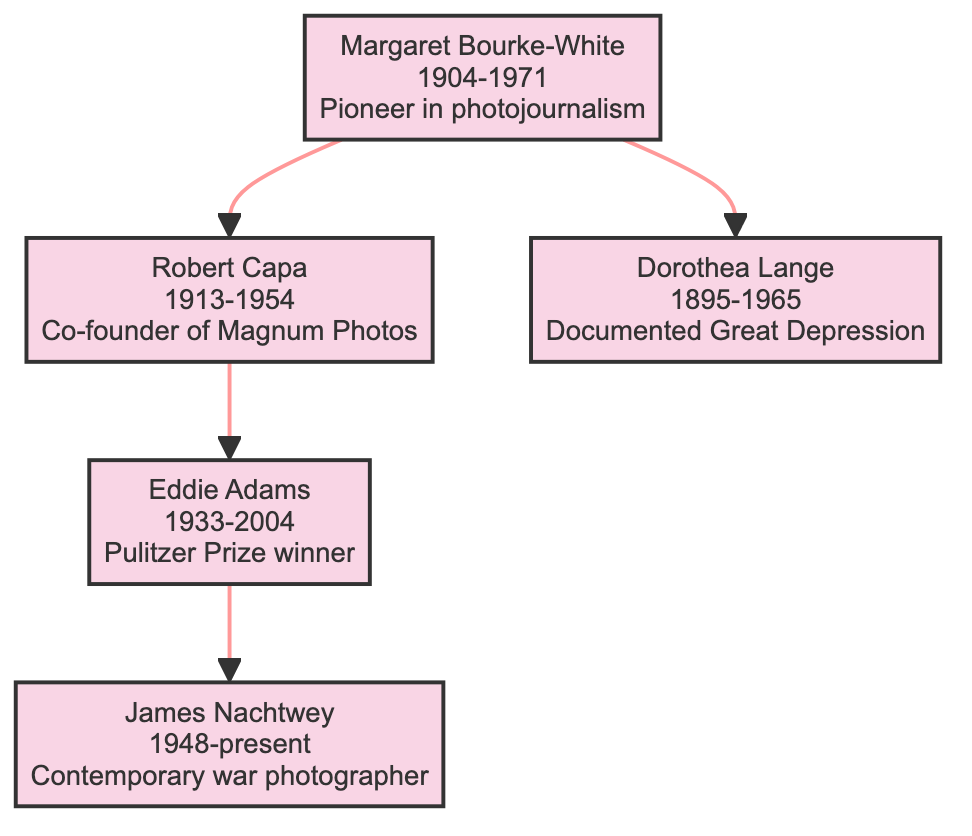What is the birth year of Margaret Bourke-White? The diagram shows the node for Margaret Bourke-White, and at the bottom of this node, it indicates the year 1904. Therefore, her birth year is 1904.
Answer: 1904 How many notable assignments did Robert Capa have? Robert Capa's node lists three notable assignments, which are the Spanish Civil War, D-Day landings, and the First Indochina War. The total count of these assignments is three.
Answer: 3 Who documented the Great Depression? The diagram points to Dorothea Lange’s node, which states "Documented the effects of the Great Depression." Therefore, Dorothea Lange is the person who documented the Great Depression.
Answer: Dorothea Lange Which photojournalist co-founded Magnum Photos? The information in the diagram states that Robert Capa is noted as the co-founder of Magnum Photos, making him the correct answer to this question.
Answer: Robert Capa Who is the contemporary war photographer in the family tree? Looking at the diagram, James Nachtwey is labeled as a "Contemporary war photographer," indicating that he fits this description.
Answer: James Nachtwey What impact did Eddie Adams have on public opinion? The diagram notes Eddie Adams’ impact as having "highlighted the power of photojournalism in influencing public opinion," summarizing his significant role.
Answer: Highlighted the power of photojournalism Which two renowned photojournalists documented World War II events? By examining the relationships and notable assignments in the diagram, both Margaret Bourke-White and Robert Capa are linked to significant events in World War II: Bourke-White in combat zones and Capa at D-Day.
Answer: Margaret Bourke-White and Robert Capa How are Margaret Bourke-White and Dorothea Lange related in the family tree? The diagram shows a direct descendant relationship where Margaret Bourke-White is a parent to Dorothea Lange, indicating she is Dorothea Lange's ancestor in the family tree.
Answer: Ancestor How many generations of photojournalists does the tree represent? The diagram contains five nodes: Margaret Bourke-White, Robert Capa, Eddie Adams, Dorothea Lange, and James Nachtwey. By counting these nodes, we see that there are three generations represented: Bourke-White (the founding generation), Capa and Lange (the second generation), and Adams and Nachtwey (the third generation).
Answer: Three generations 